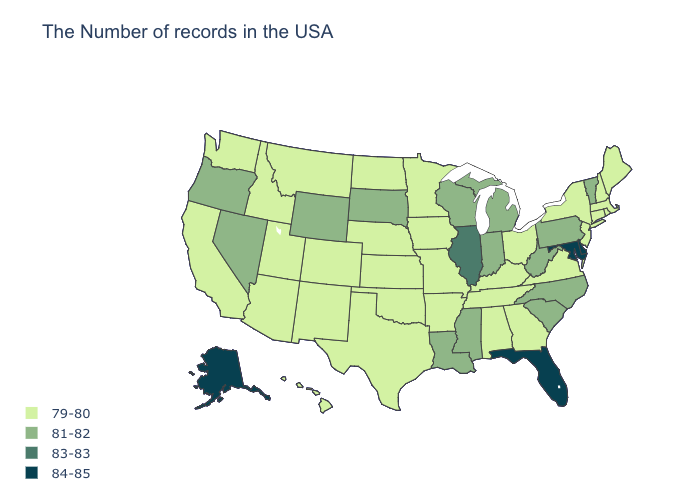Name the states that have a value in the range 83-83?
Give a very brief answer. Illinois. What is the value of Maine?
Concise answer only. 79-80. What is the lowest value in states that border Nebraska?
Be succinct. 79-80. Does Virginia have the lowest value in the USA?
Be succinct. Yes. What is the lowest value in the USA?
Keep it brief. 79-80. Does Louisiana have the lowest value in the South?
Short answer required. No. What is the value of Nebraska?
Be succinct. 79-80. What is the value of Michigan?
Short answer required. 81-82. What is the lowest value in states that border Michigan?
Write a very short answer. 79-80. Name the states that have a value in the range 79-80?
Write a very short answer. Maine, Massachusetts, Rhode Island, New Hampshire, Connecticut, New York, New Jersey, Virginia, Ohio, Georgia, Kentucky, Alabama, Tennessee, Missouri, Arkansas, Minnesota, Iowa, Kansas, Nebraska, Oklahoma, Texas, North Dakota, Colorado, New Mexico, Utah, Montana, Arizona, Idaho, California, Washington, Hawaii. Does Oregon have the lowest value in the West?
Quick response, please. No. What is the lowest value in the South?
Quick response, please. 79-80. Does New Mexico have the highest value in the USA?
Concise answer only. No. What is the value of South Dakota?
Short answer required. 81-82. 